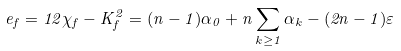Convert formula to latex. <formula><loc_0><loc_0><loc_500><loc_500>e _ { f } = 1 2 \chi _ { f } - K _ { f } ^ { 2 } = ( n - 1 ) \alpha _ { 0 } + n \sum _ { k \geq 1 } \alpha _ { k } - ( 2 n - 1 ) \varepsilon</formula> 